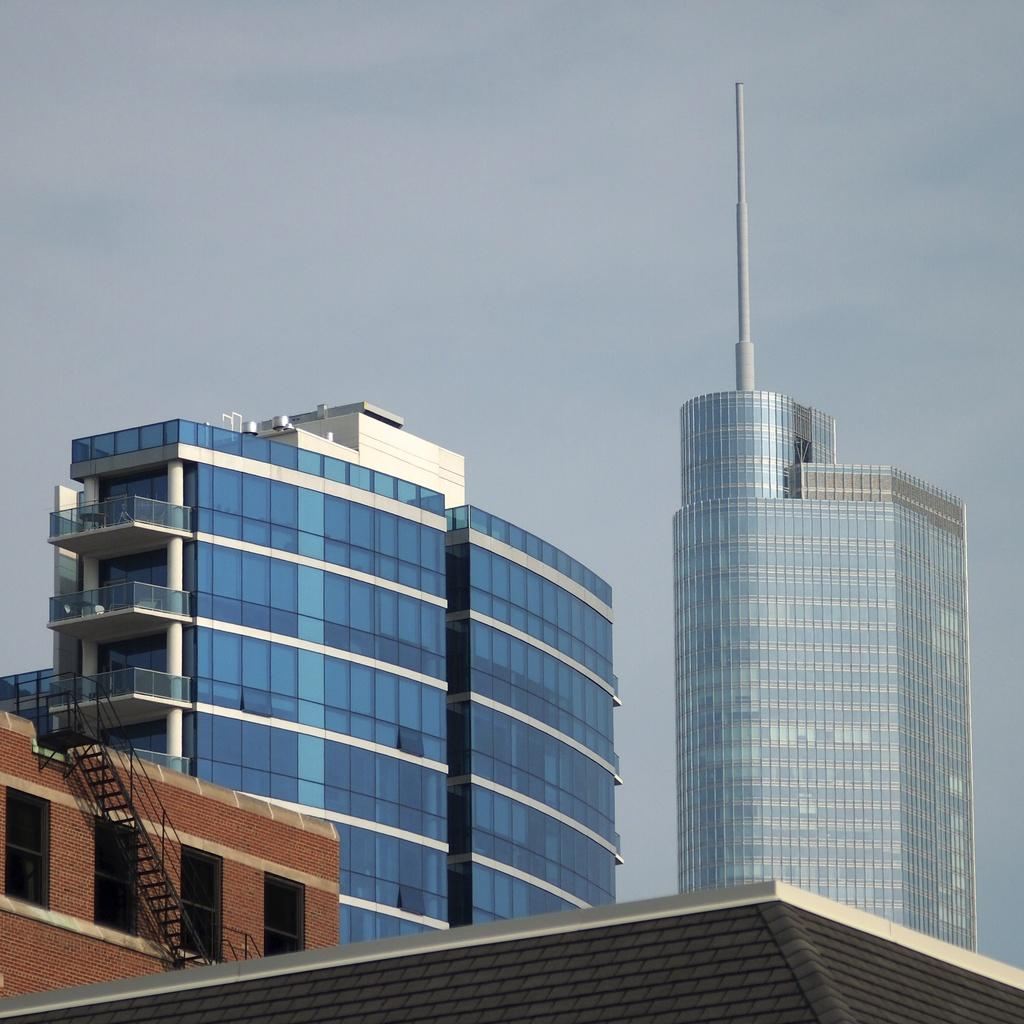What is the main feature in the center of the image? The center of the image contains the sky. What can be seen in the sky? Clouds are visible in the image. What type of structures are present in the image? There are buildings in the image. What are some additional details about the buildings? Fences and windows are visible in the image. Are there any other objects or features in the image? Yes, there is a pole and a staircase present in the image. What type of prose is being recited by the silver statue in the image? There is no statue, silver or otherwise, present in the image. What offer is being made by the person holding the silver tray in the image? There is no person holding a silver tray in the image. 